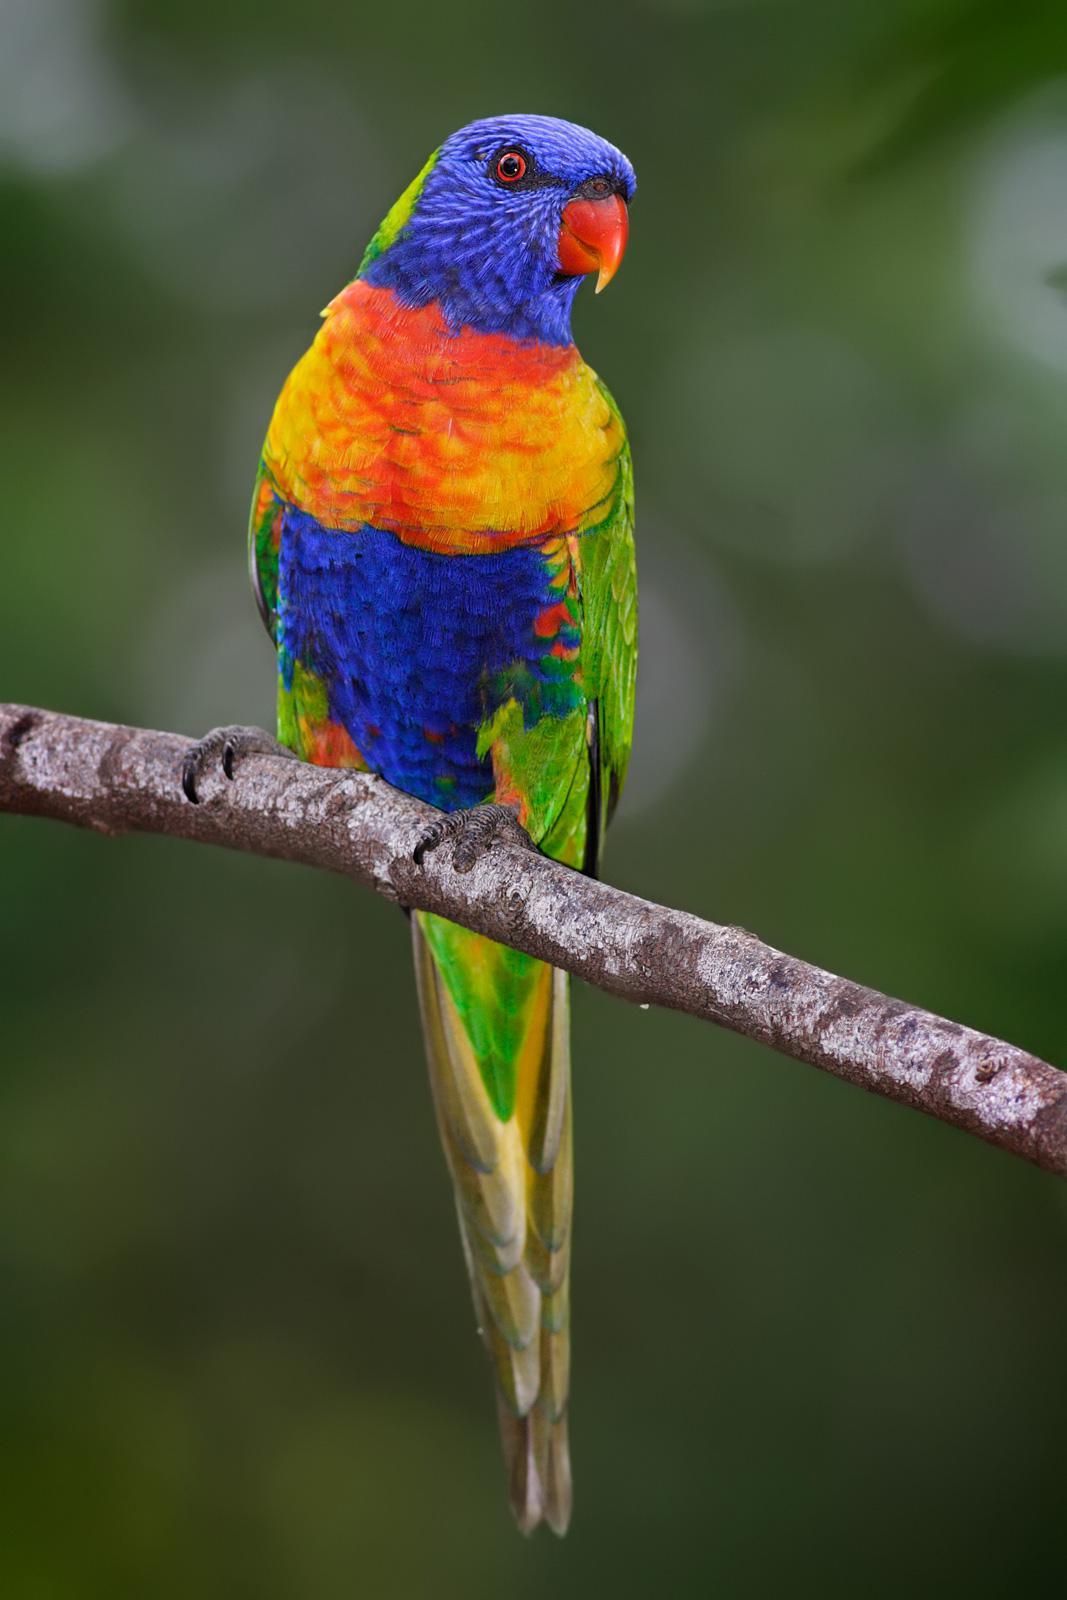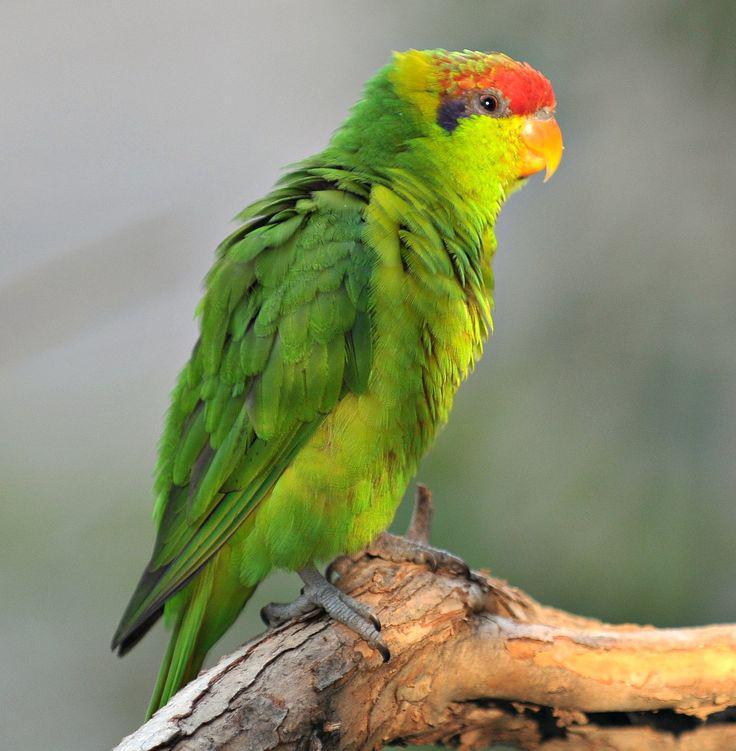The first image is the image on the left, the second image is the image on the right. Given the left and right images, does the statement "Exactly two parrots are sitting on tree branches, both of them having at least some green on their bodies, but only one with a blue head." hold true? Answer yes or no. Yes. The first image is the image on the left, the second image is the image on the right. Examine the images to the left and right. Is the description "The left image shows exactly one parrot, and it is perched on a wooden limb." accurate? Answer yes or no. Yes. 